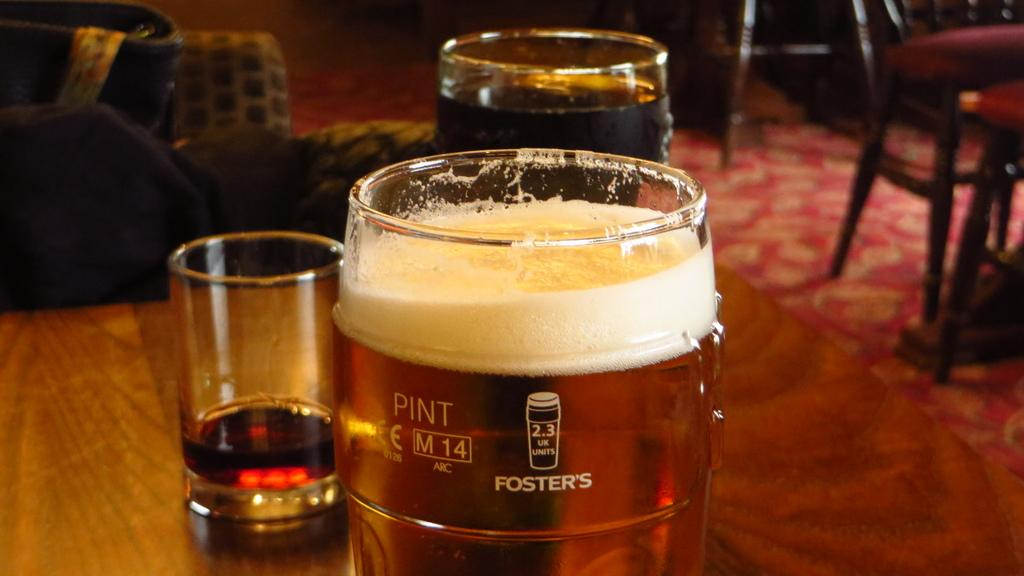<image>
Create a compact narrative representing the image presented. A glass on a wooden table says Foster's and is full of beer. 